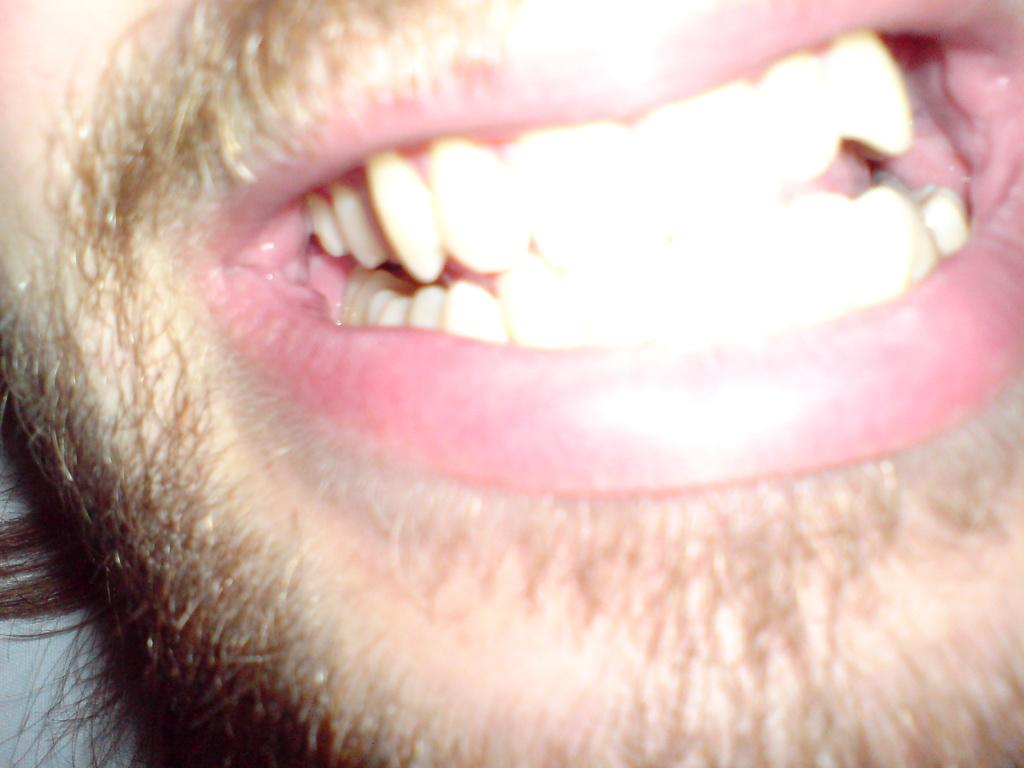What can be seen in the image that is related to the human body? There are teeth visible in the image. What type of skirt is being worn by the horse in the image? There is no horse or skirt present in the image; it only features teeth. 